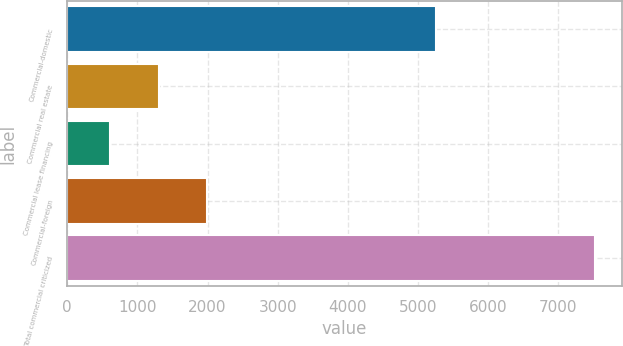Convert chart to OTSL. <chart><loc_0><loc_0><loc_500><loc_500><bar_chart><fcel>Commercial-domestic<fcel>Commercial real estate<fcel>Commercial lease financing<fcel>Commercial-foreign<fcel>Total commercial criticized<nl><fcel>5259<fcel>1302.6<fcel>611<fcel>1994.2<fcel>7527<nl></chart> 